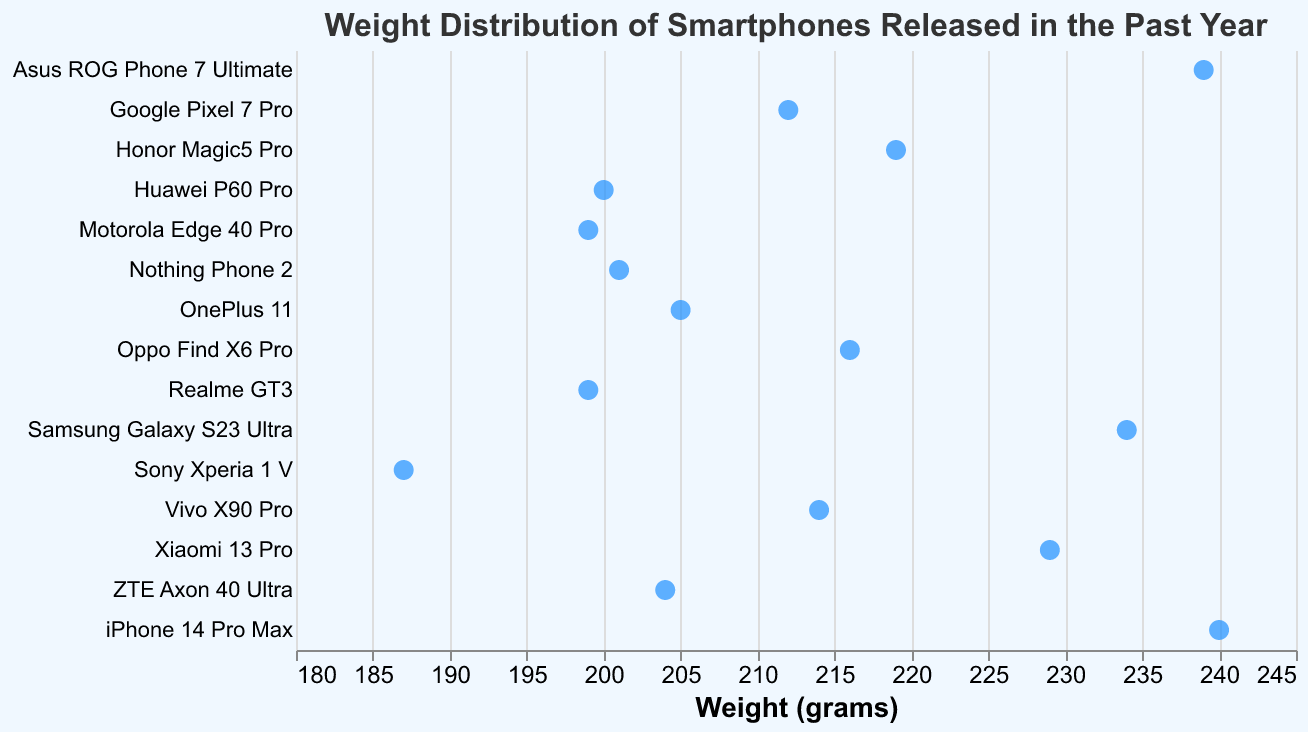What is the heaviest smartphone in the list? The plot shows the weight of each smartphone with dots horizontally aligned by weight. The heaviest dot is at 240 grams.
Answer: iPhone 14 Pro Max Which smartphone is the lightest? The plot shows dots distributed horizontally from left to right based on weight. The smallest value on the x-axis is 187 grams.
Answer: Sony Xperia 1 V What is the name of the plot? The title of the plot appears at the top and describes the figure.
Answer: Weight Distribution of Smartphones Released in the Past Year Which two smartphones have the closest weights? By identifying the smallest gap between two adjacent dots along the x-axis, we see that 199 grams is shared by two different brands.
Answer: Motorola Edge 40 Pro and Realme GT3 What is the weight range of smartphones in this plot? The plot's x-axis starts at 180 grams and ends at 245 grams; the lightest phone is 187 grams, and the heaviest is 240 grams.
Answer: 53 grams What is the average weight of all these smartphones? Adding all the weight values and dividing by the number of smartphones: (240 + 234 + 212 + 205 + 229 + 187 + 239 + 216 + 214 + 199 + 201 + 199 + 200 + 204 + 219) / 15 = 213.33 grams.
Answer: 213.33 grams Which smartphone weighs more, Oppo Find X6 Pro or Vivo X90 Pro? Looking at the horizontal position of the dots for these two brands, Oppo Find X6 Pro is at 216 grams, and Vivo X90 Pro is at 214 grams.
Answer: Oppo Find X6 Pro Which smartphone weighs more, OnePlus 11 or ZTE Axon 40 Ultra? Referring to their positions along the horizontal axis: OnePlus 11 weighs 205 grams, and ZTE Axon 40 Ultra weighs 204 grams.
Answer: OnePlus 11 Who is heavier, Samsung Galaxy S23 Ultra or Xiaomi 13 Pro? Referring the positions along the horizontal axis: Samsung Galaxy S23 Ultra weighs 234 grams, and Xiaomi 13 Pro weighs 229 grams.
Answer: Samsung Galaxy S23 Ultra 